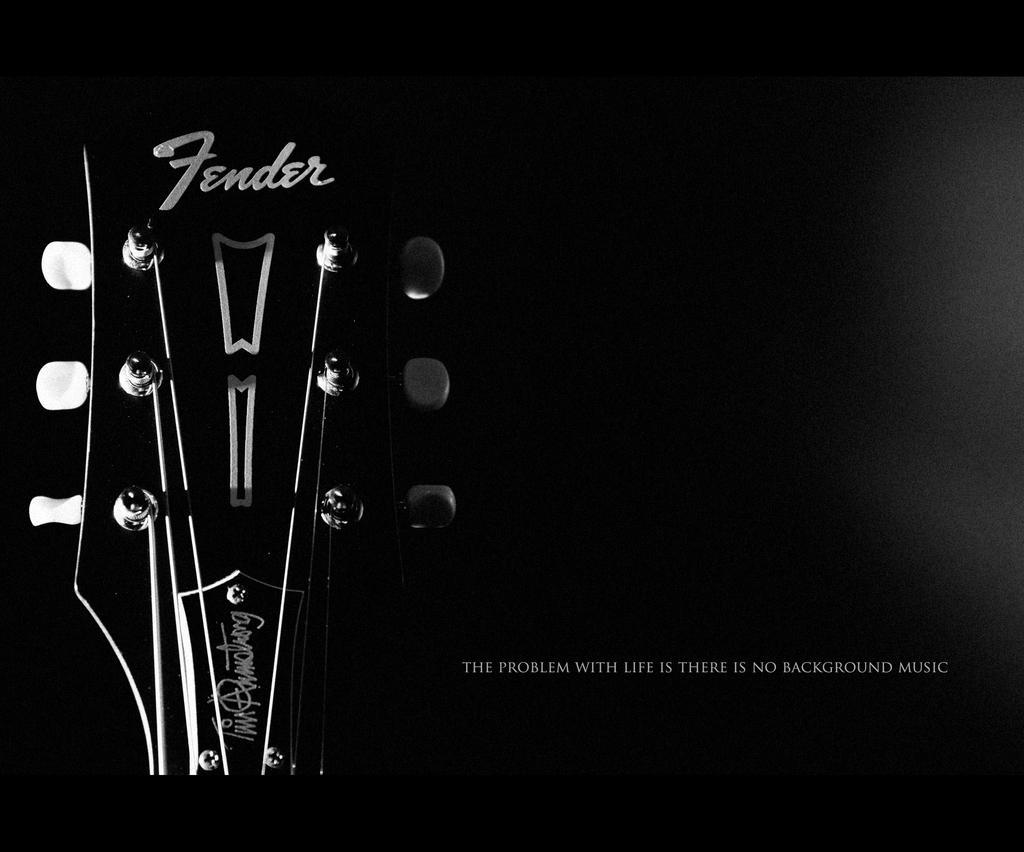Can you describe this image briefly? In this picture I can see guitar and I can see text at the bottom right side of the picture and I can see text on the guitar and I can see dark background. 